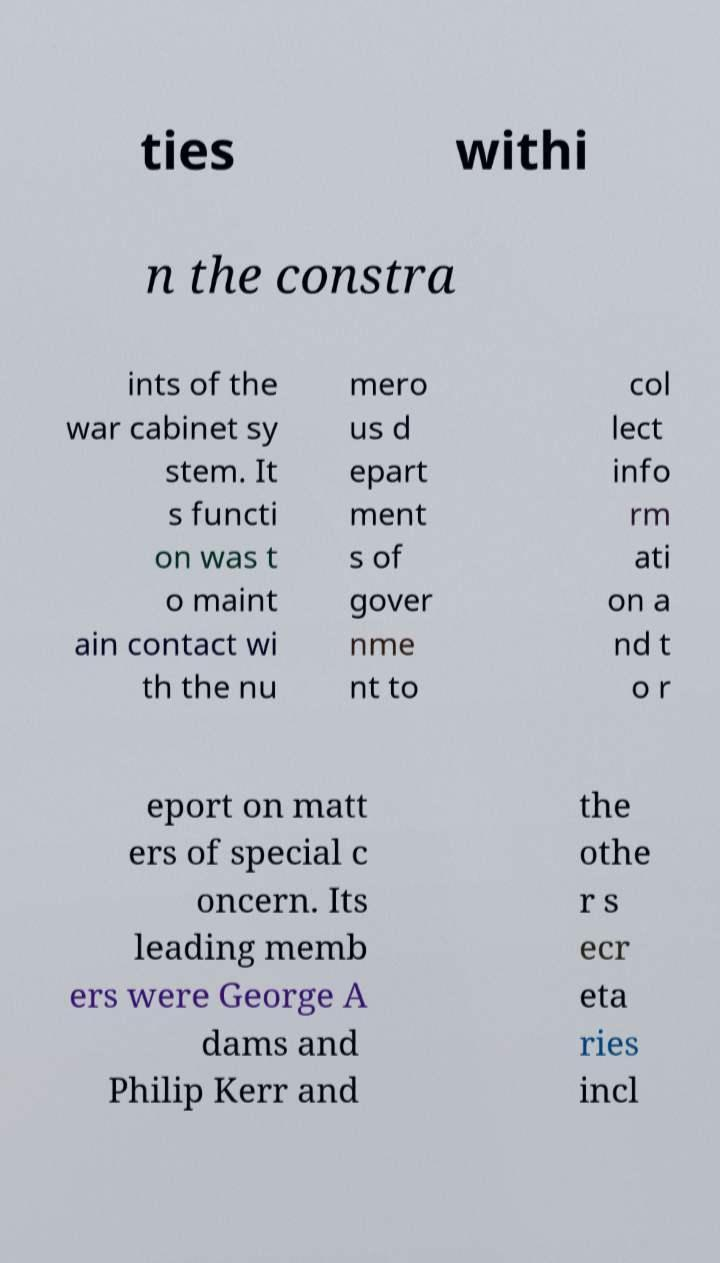Could you assist in decoding the text presented in this image and type it out clearly? ties withi n the constra ints of the war cabinet sy stem. It s functi on was t o maint ain contact wi th the nu mero us d epart ment s of gover nme nt to col lect info rm ati on a nd t o r eport on matt ers of special c oncern. Its leading memb ers were George A dams and Philip Kerr and the othe r s ecr eta ries incl 